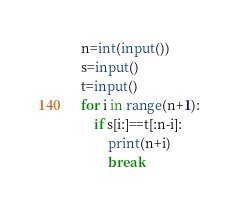Convert code to text. <code><loc_0><loc_0><loc_500><loc_500><_Python_>n=int(input())
s=input()
t=input()
for i in range(n+1):
    if s[i:]==t[:n-i]:
        print(n+i)
        break</code> 